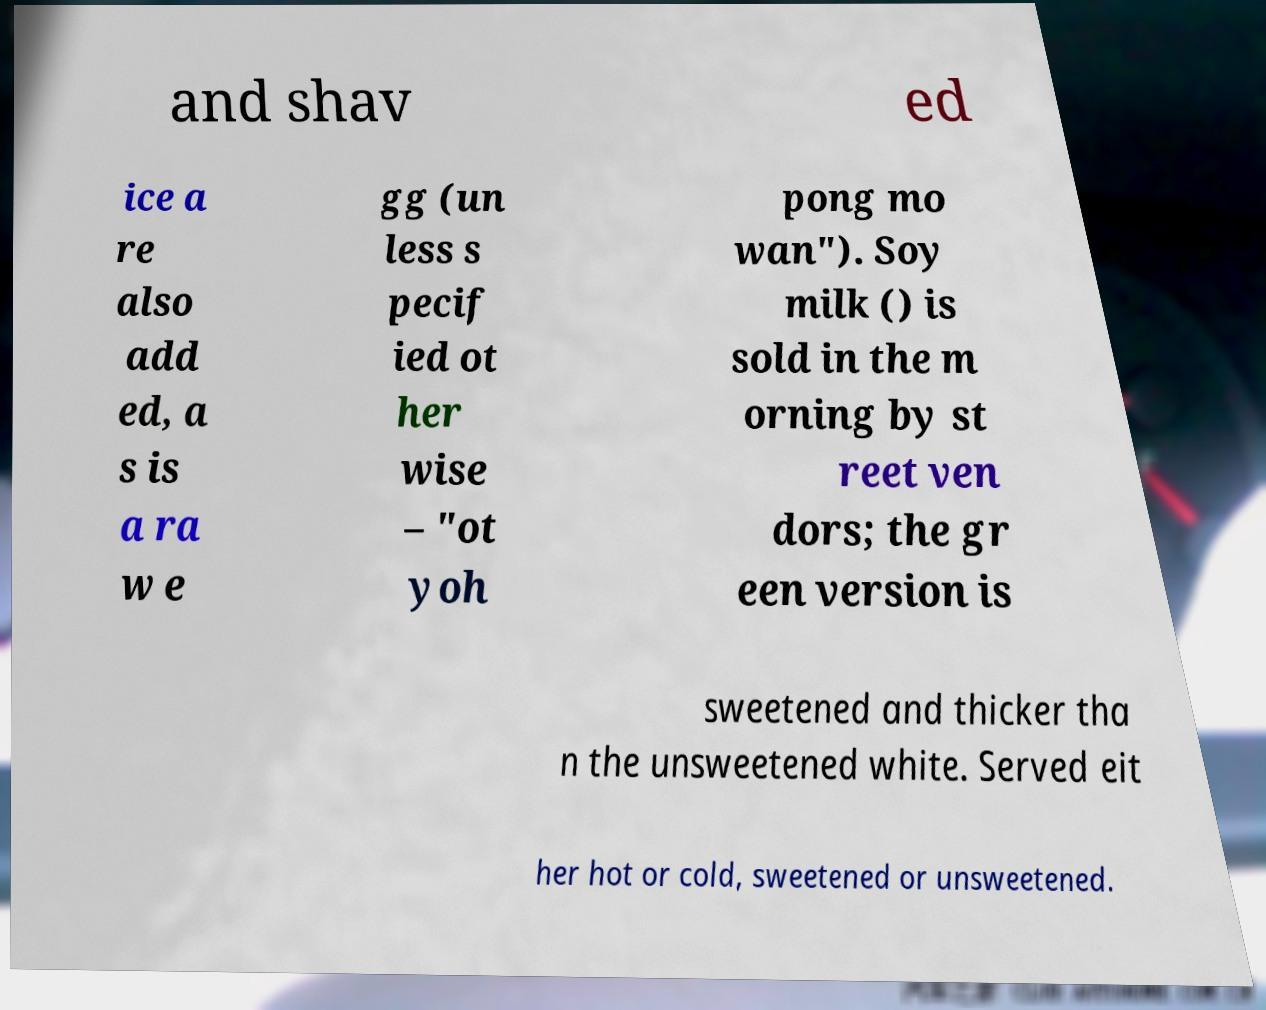Can you read and provide the text displayed in the image?This photo seems to have some interesting text. Can you extract and type it out for me? and shav ed ice a re also add ed, a s is a ra w e gg (un less s pecif ied ot her wise – "ot yoh pong mo wan"). Soy milk () is sold in the m orning by st reet ven dors; the gr een version is sweetened and thicker tha n the unsweetened white. Served eit her hot or cold, sweetened or unsweetened. 